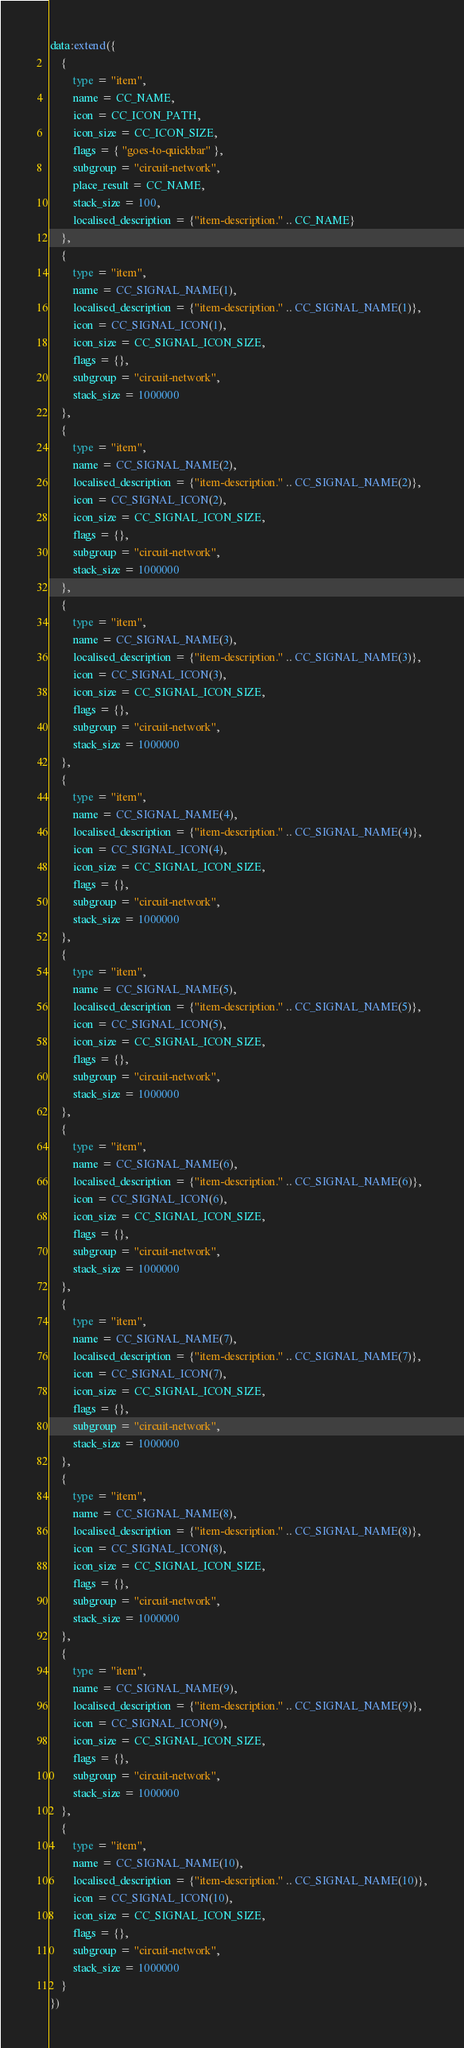Convert code to text. <code><loc_0><loc_0><loc_500><loc_500><_Lua_>data:extend({
	{
		type = "item",
		name = CC_NAME,
		icon = CC_ICON_PATH,
		icon_size = CC_ICON_SIZE,
		flags = { "goes-to-quickbar" },
		subgroup = "circuit-network",
		place_result = CC_NAME,
		stack_size = 100,
		localised_description = {"item-description." .. CC_NAME}
	},
	{
		type = "item",
		name = CC_SIGNAL_NAME(1),
		localised_description = {"item-description." .. CC_SIGNAL_NAME(1)},
		icon = CC_SIGNAL_ICON(1),
		icon_size = CC_SIGNAL_ICON_SIZE,
		flags = {},
		subgroup = "circuit-network",
		stack_size = 1000000
	},
	{
		type = "item",
		name = CC_SIGNAL_NAME(2),
		localised_description = {"item-description." .. CC_SIGNAL_NAME(2)},
		icon = CC_SIGNAL_ICON(2),
		icon_size = CC_SIGNAL_ICON_SIZE,
		flags = {},
		subgroup = "circuit-network",
		stack_size = 1000000
	},
	{
		type = "item",
		name = CC_SIGNAL_NAME(3),
		localised_description = {"item-description." .. CC_SIGNAL_NAME(3)},
		icon = CC_SIGNAL_ICON(3),
		icon_size = CC_SIGNAL_ICON_SIZE,
		flags = {},
		subgroup = "circuit-network",
		stack_size = 1000000
	},
	{
		type = "item",
		name = CC_SIGNAL_NAME(4),
		localised_description = {"item-description." .. CC_SIGNAL_NAME(4)},
		icon = CC_SIGNAL_ICON(4),
		icon_size = CC_SIGNAL_ICON_SIZE,
		flags = {},
		subgroup = "circuit-network",
		stack_size = 1000000
	},
	{
		type = "item",
		name = CC_SIGNAL_NAME(5),
		localised_description = {"item-description." .. CC_SIGNAL_NAME(5)},
		icon = CC_SIGNAL_ICON(5),
		icon_size = CC_SIGNAL_ICON_SIZE,
		flags = {},
		subgroup = "circuit-network",
		stack_size = 1000000
	},
	{
		type = "item",
		name = CC_SIGNAL_NAME(6),
		localised_description = {"item-description." .. CC_SIGNAL_NAME(6)},
		icon = CC_SIGNAL_ICON(6),
		icon_size = CC_SIGNAL_ICON_SIZE,
		flags = {},
		subgroup = "circuit-network",
		stack_size = 1000000
	},
	{
		type = "item",
		name = CC_SIGNAL_NAME(7),
		localised_description = {"item-description." .. CC_SIGNAL_NAME(7)},
		icon = CC_SIGNAL_ICON(7),
		icon_size = CC_SIGNAL_ICON_SIZE,
		flags = {},
		subgroup = "circuit-network",
		stack_size = 1000000
	},
	{
		type = "item",
		name = CC_SIGNAL_NAME(8),
		localised_description = {"item-description." .. CC_SIGNAL_NAME(8)},
		icon = CC_SIGNAL_ICON(8),
		icon_size = CC_SIGNAL_ICON_SIZE,
		flags = {},
		subgroup = "circuit-network",
		stack_size = 1000000
	},
	{
		type = "item",
		name = CC_SIGNAL_NAME(9),
		localised_description = {"item-description." .. CC_SIGNAL_NAME(9)},
		icon = CC_SIGNAL_ICON(9),
		icon_size = CC_SIGNAL_ICON_SIZE,
		flags = {},
		subgroup = "circuit-network",
		stack_size = 1000000
	},
	{
		type = "item",
		name = CC_SIGNAL_NAME(10),
		localised_description = {"item-description." .. CC_SIGNAL_NAME(10)},
		icon = CC_SIGNAL_ICON(10),
		icon_size = CC_SIGNAL_ICON_SIZE,
		flags = {},
		subgroup = "circuit-network",
		stack_size = 1000000
	}
})
</code> 